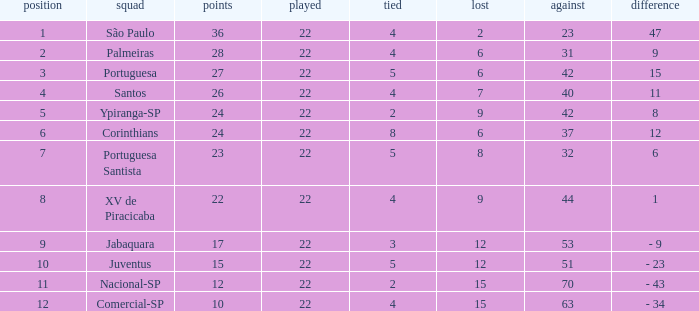Which Played has a Lost larger than 9, and a Points smaller than 15, and a Position smaller than 12, and a Drawn smaller than 2? None. 